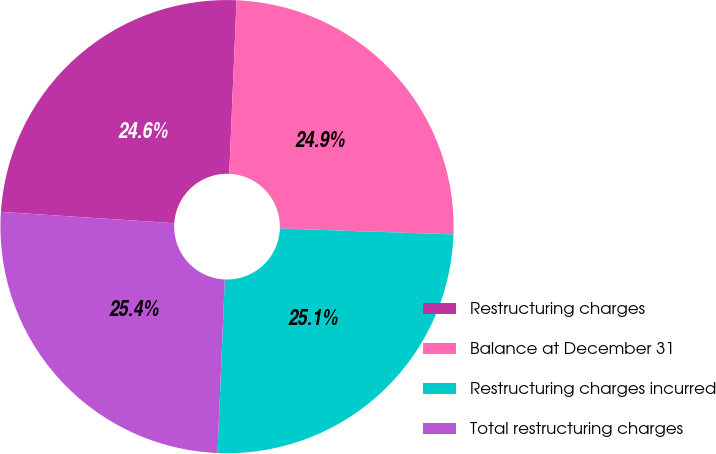<chart> <loc_0><loc_0><loc_500><loc_500><pie_chart><fcel>Restructuring charges<fcel>Balance at December 31<fcel>Restructuring charges incurred<fcel>Total restructuring charges<nl><fcel>24.63%<fcel>24.88%<fcel>25.12%<fcel>25.37%<nl></chart> 